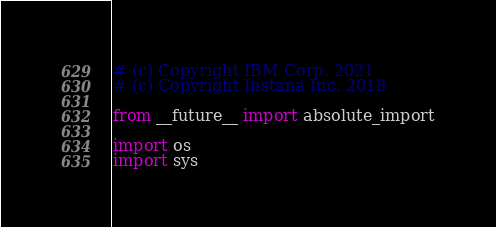Convert code to text. <code><loc_0><loc_0><loc_500><loc_500><_Python_># (c) Copyright IBM Corp. 2021
# (c) Copyright Instana Inc. 2018

from __future__ import absolute_import

import os
import sys
</code> 